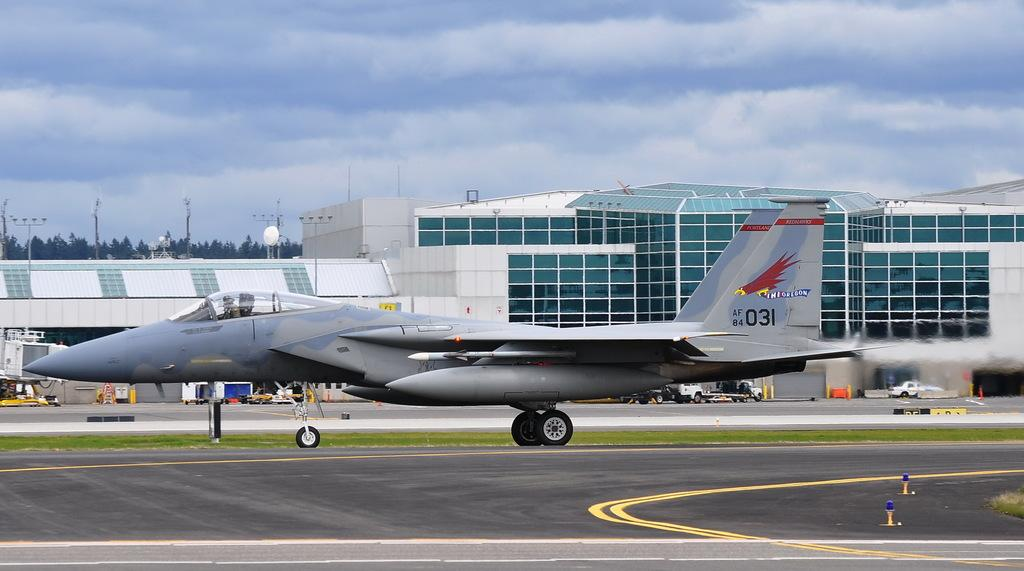<image>
Offer a succinct explanation of the picture presented. a pane that says ini oregon af 84 031 on the side of it 